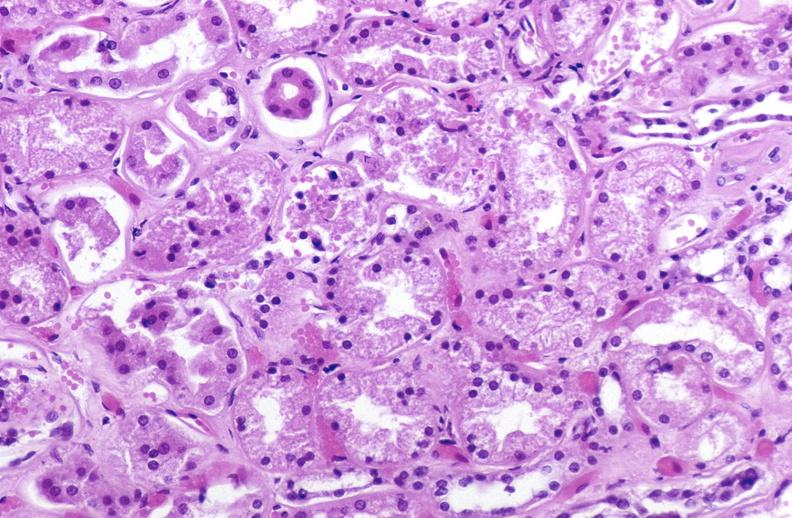s urinary present?
Answer the question using a single word or phrase. Yes 